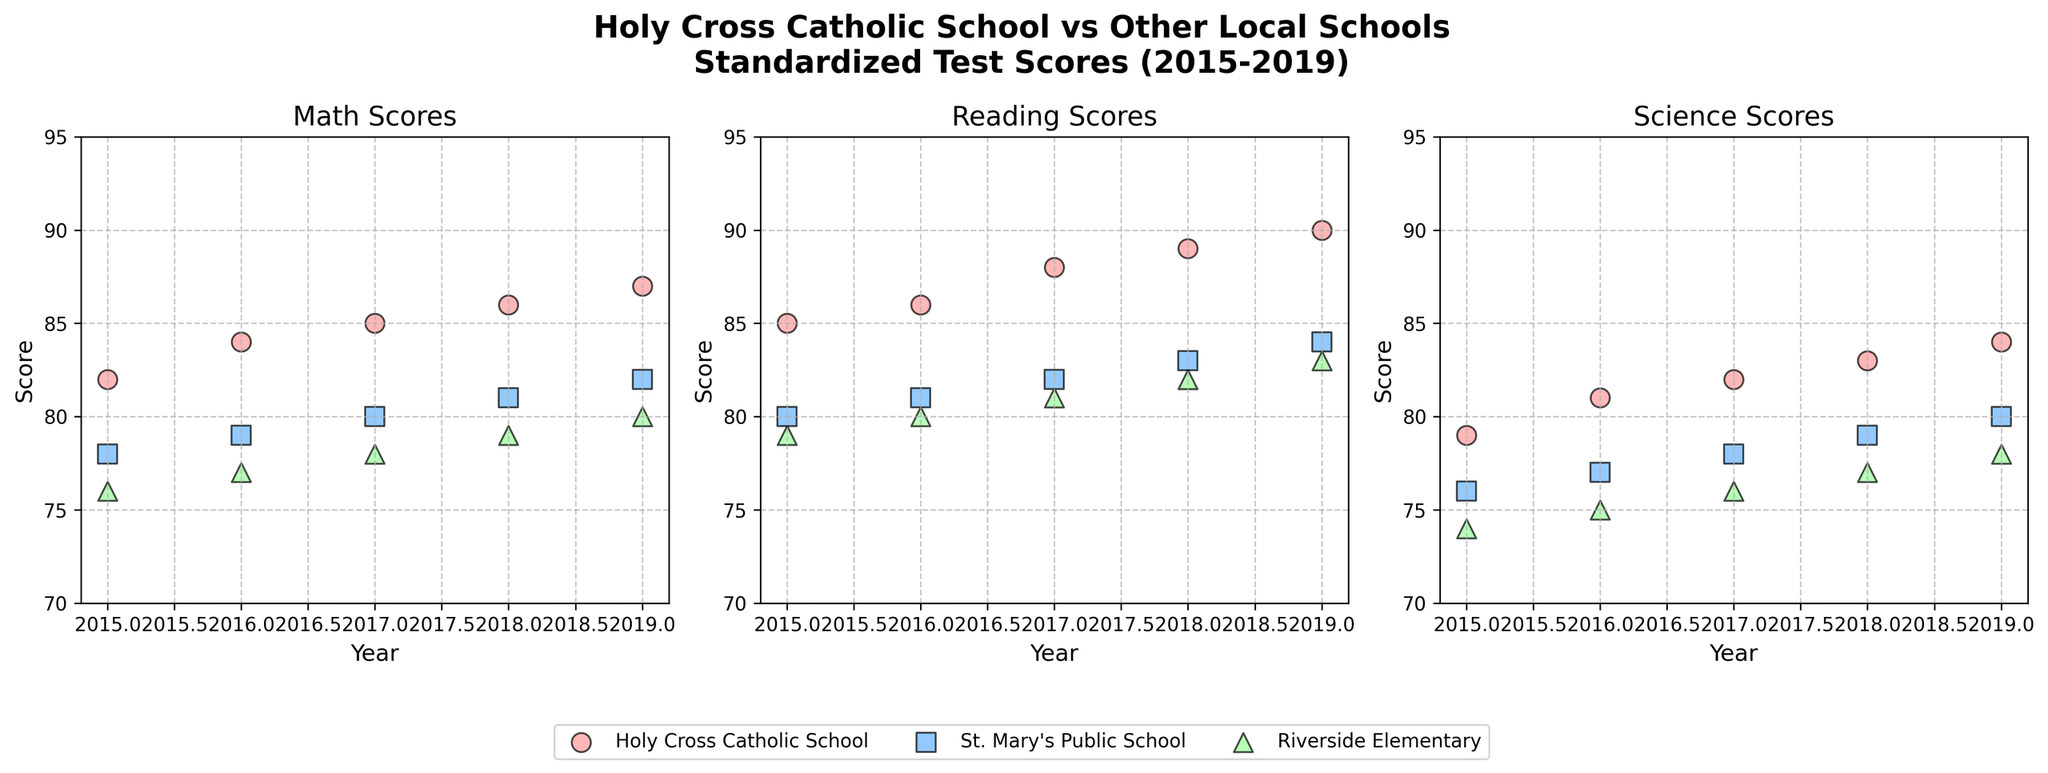What is the title of the figure? The title is usually located at the top of the figure and provides an overview of what the figure represents. The title of this figure is "Holy Cross Catholic School vs Other Local Schools\nStandardized Test Scores (2015-2019)".
Answer: Holy Cross Catholic School vs Other Local Schools\nStandardized Test Scores (2015-2019) What is the highest Math Score for Riverside Elementary in 2019? Looking at the scatter plot for Math scores, identify the year 2019 and find the corresponding point for Riverside Elementary. The highest Math Score for Riverside Elementary in 2019 is 80.
Answer: 80 What is the overall trend of Math Scores for Holy Cross Catholic School from 2015 to 2019? Locate the Math Scores over years 2015 to 2019 for Holy Cross Catholic School in the figure. Track how the scores change over these years. The trend indicates a steady increase from 82 in 2015 to 87 in 2019.
Answer: Increasing Which school had the highest Science Score in 2017? Scan the Science scores section and identify the points corresponding to the year 2017. Compare the scores for each school and see that Holy Cross Catholic School had the highest Science Score in 2017 with a score of 82.
Answer: Holy Cross Catholic School How do the Reading Scores for Holy Cross Catholic School compare to St. Mary's Public School in 2018? In the Reading Scores section, find the points corresponding to the year 2018 for both Holy Cross Catholic School and St. Mary's Public School. Compare the scores, which are 89 for Holy Cross and 83 for St. Mary's Public School, so Holy Cross is higher.
Answer: Holy Cross is higher By how many points did the Math Scores for Holy Cross Catholic School improve from 2016 to 2018? Identify the Math Scores for Holy Cross Catholic School in 2016 and 2018, which are 84 and 86 respectively. Calculate the difference: 86 - 84 = 2.
Answer: 2 points Which subject shows the most consistent improvement for Holy Cross Catholic School between 2015 and 2019? Examining the trends for all subjects, check which one shows a steady upward trend without dips: Math (82 to 87), Reading (85 to 90), and Science (79 to 84). All improve, but Reading having the steadiest upward trend.
Answer: Reading Compare the changes in Science Scores for Riverside Elementary between 2015 and 2019. Examine the Science Scores for the years 2015 and 2019, which are 74 and 78 respectively. Calculate the difference to see an improvement. 78 - 74 = 4.
Answer: Increased by 4 points What is the difference in Reading Scores between Holy Cross Catholic School and Riverside Elementary in 2019? Find the Reading Scores for both schools in 2019, which are 90 for Holy Cross and 83 for Riverside Elementary. Calculate the difference: 90 - 83 = 7.
Answer: 7 points Looking at Math Scores, which school showed the least variability from 2015 to 2019? Examine the Math Scores for each school over the years and observe the range of scores. Holy Cross ranges from 82 to 87, St. Mary's from 78 to 82, and Riverside from 76 to 80. Riverside Elementary shows the least range from 76 to 80, hence least variability.
Answer: Riverside Elementary 